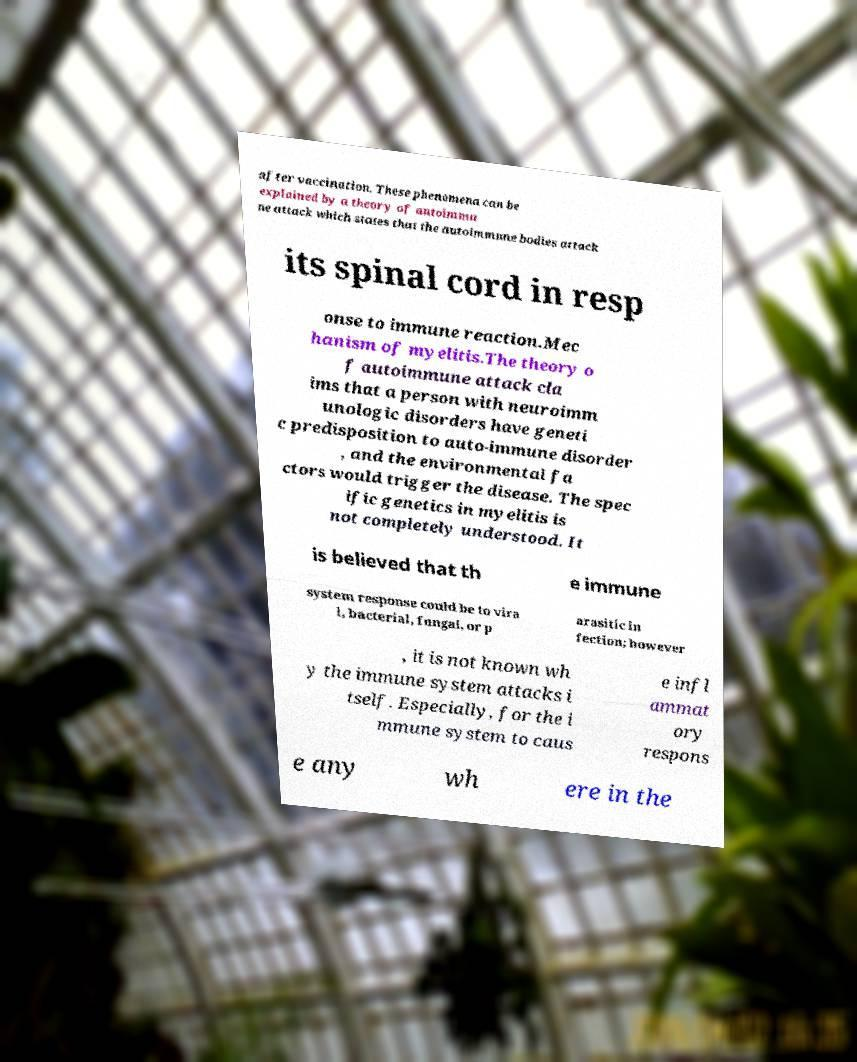Can you read and provide the text displayed in the image?This photo seems to have some interesting text. Can you extract and type it out for me? after vaccination. These phenomena can be explained by a theory of autoimmu ne attack which states that the autoimmune bodies attack its spinal cord in resp onse to immune reaction.Mec hanism of myelitis.The theory o f autoimmune attack cla ims that a person with neuroimm unologic disorders have geneti c predisposition to auto-immune disorder , and the environmental fa ctors would trigger the disease. The spec ific genetics in myelitis is not completely understood. It is believed that th e immune system response could be to vira l, bacterial, fungal, or p arasitic in fection; however , it is not known wh y the immune system attacks i tself. Especially, for the i mmune system to caus e infl ammat ory respons e any wh ere in the 